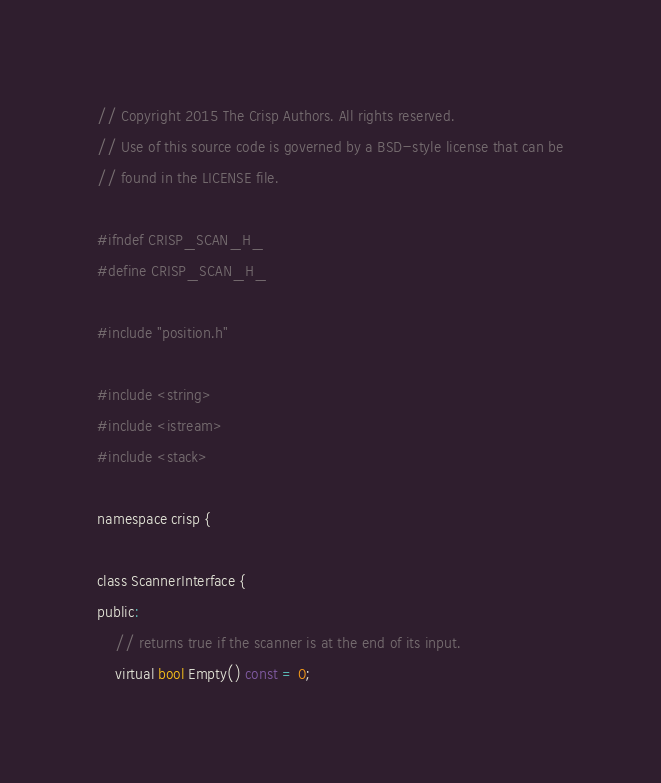<code> <loc_0><loc_0><loc_500><loc_500><_C_>
// Copyright 2015 The Crisp Authors. All rights reserved.
// Use of this source code is governed by a BSD-style license that can be
// found in the LICENSE file.

#ifndef CRISP_SCAN_H_
#define CRISP_SCAN_H_

#include "position.h"

#include <string>
#include <istream>
#include <stack>

namespace crisp {

class ScannerInterface {
public:
	// returns true if the scanner is at the end of its input.
	virtual bool Empty() const = 0;
</code> 